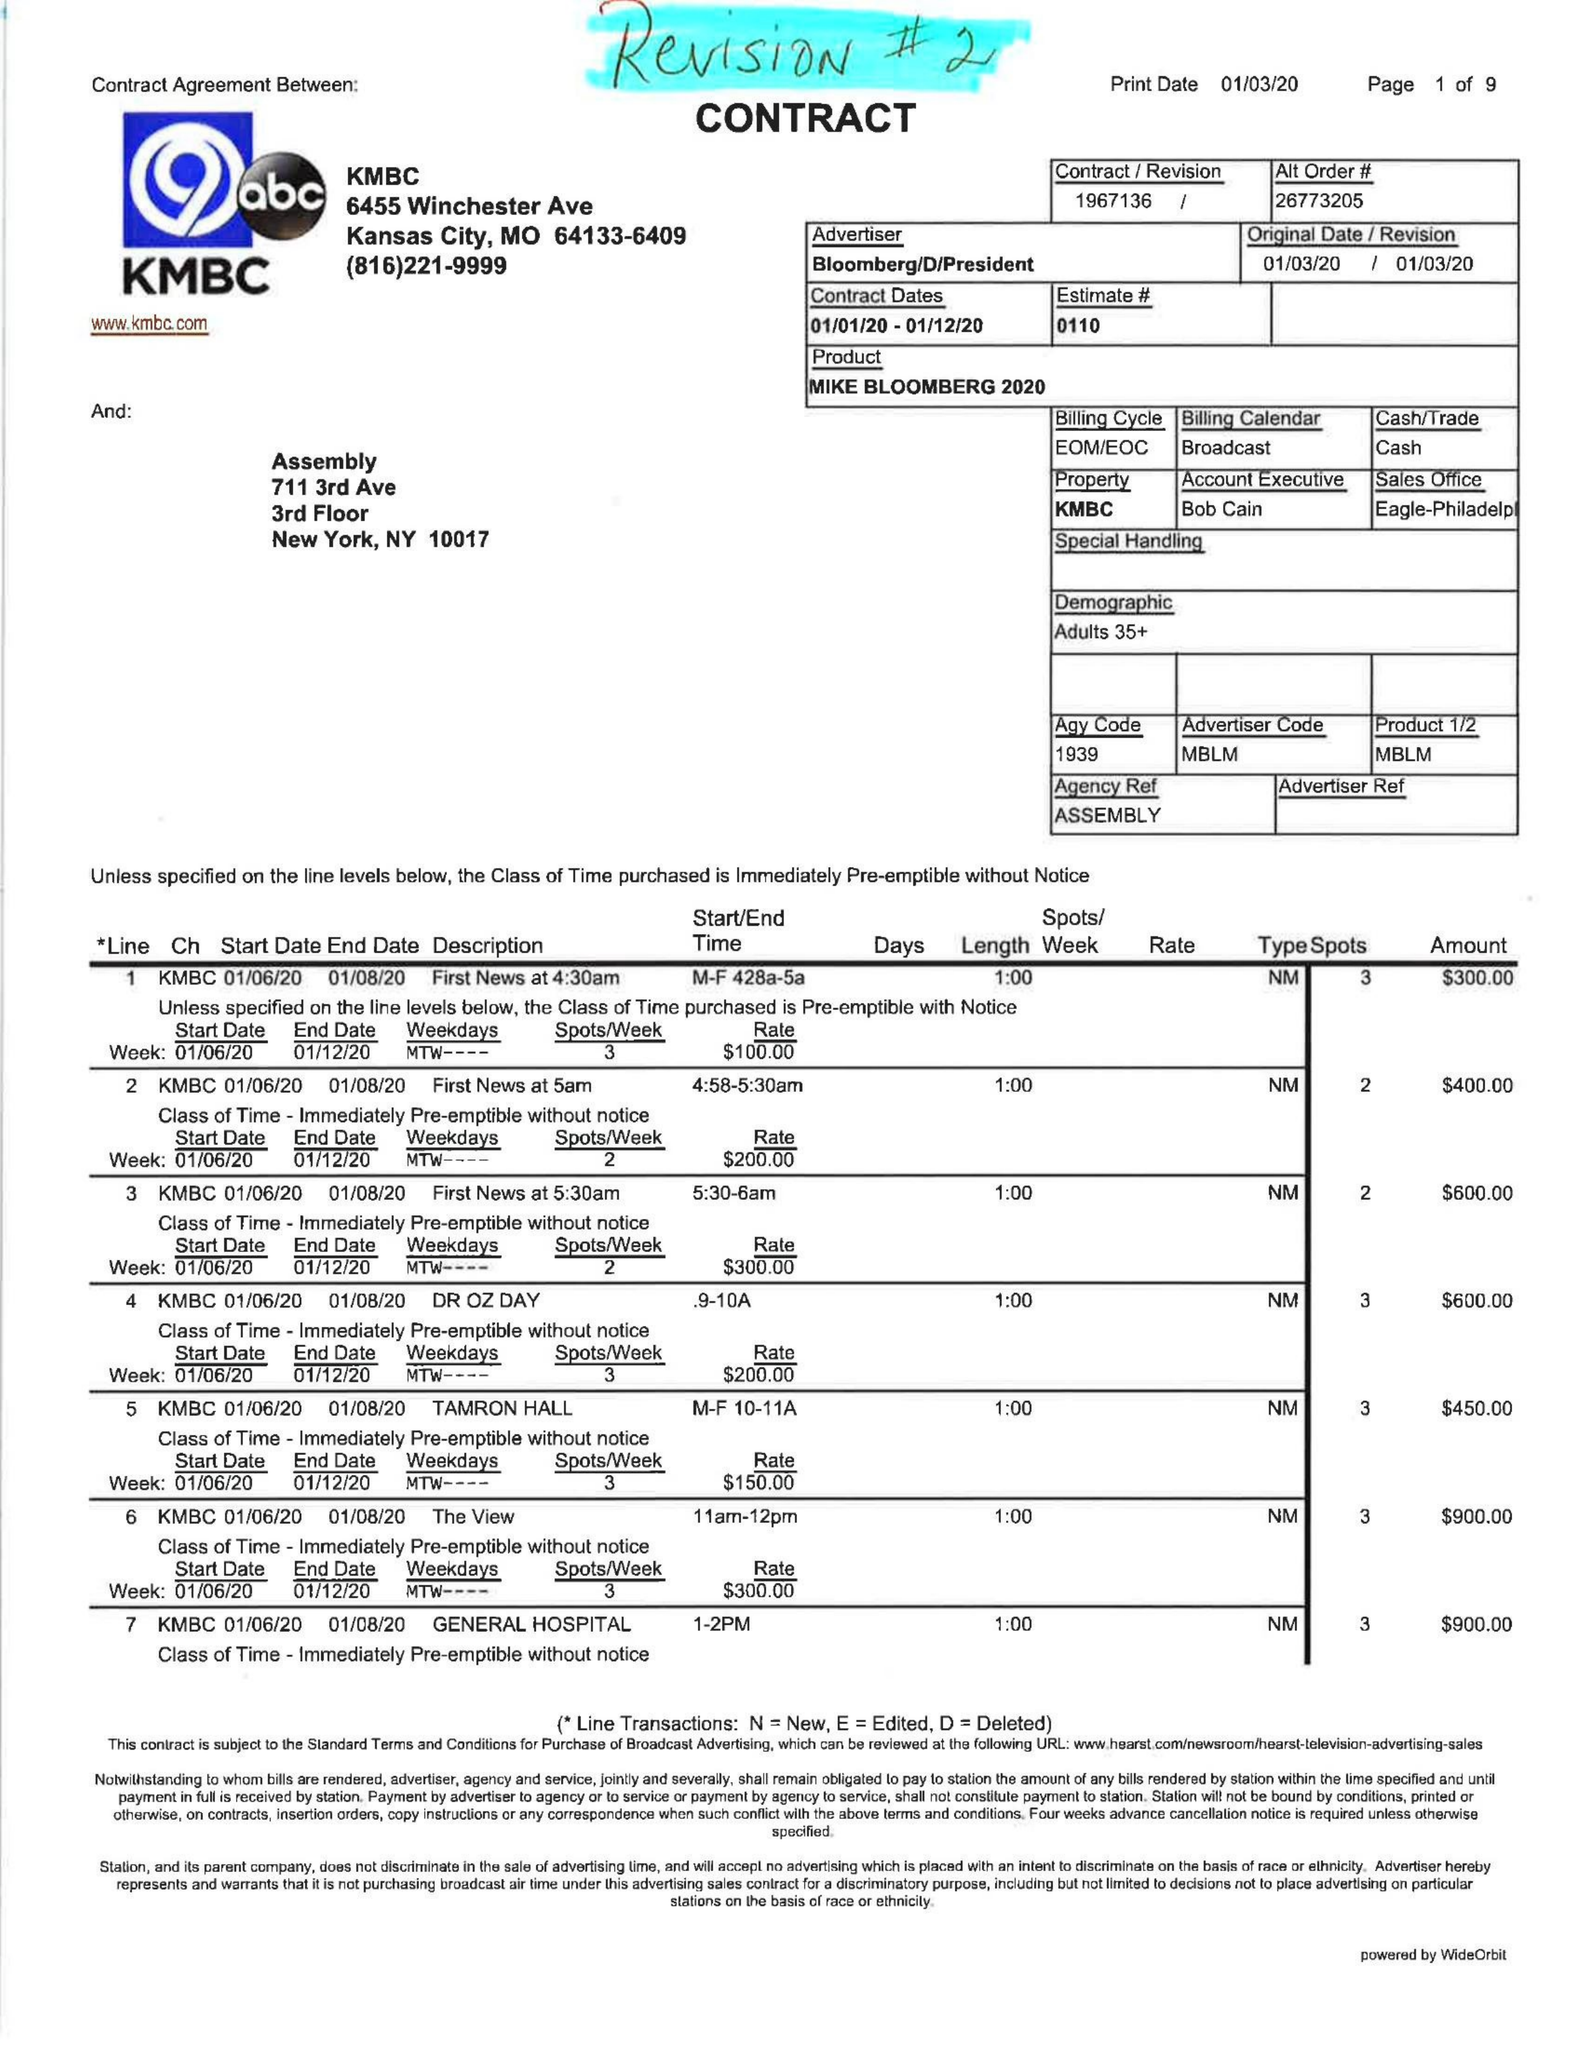What is the value for the flight_to?
Answer the question using a single word or phrase. 01/12/20 